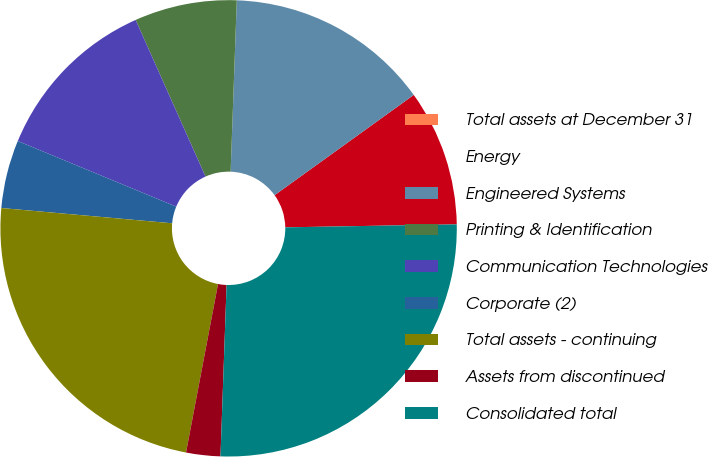<chart> <loc_0><loc_0><loc_500><loc_500><pie_chart><fcel>Total assets at December 31<fcel>Energy<fcel>Engineered Systems<fcel>Printing & Identification<fcel>Communication Technologies<fcel>Corporate (2)<fcel>Total assets - continuing<fcel>Assets from discontinued<fcel>Consolidated total<nl><fcel>0.0%<fcel>9.66%<fcel>14.49%<fcel>7.25%<fcel>12.07%<fcel>4.83%<fcel>23.43%<fcel>2.42%<fcel>25.84%<nl></chart> 